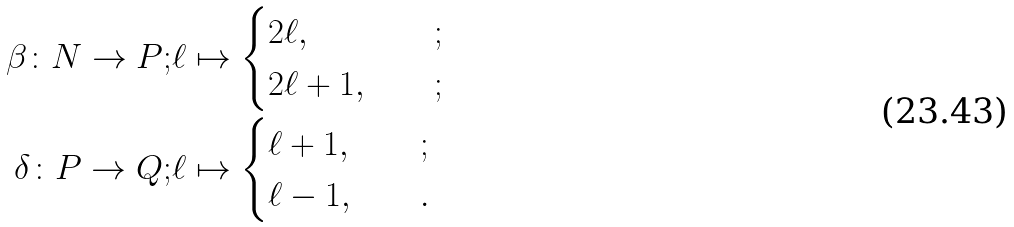Convert formula to latex. <formula><loc_0><loc_0><loc_500><loc_500>\beta \colon N \rightarrow P ; & \ell \mapsto \begin{cases} 2 \ell , & \quad ; \\ 2 \ell + 1 , & \quad ; \end{cases} \\ \delta \colon P \rightarrow Q ; & \ell \mapsto \begin{cases} \ell + 1 , & \quad ; \\ \ell - 1 , & \quad . \end{cases}</formula> 